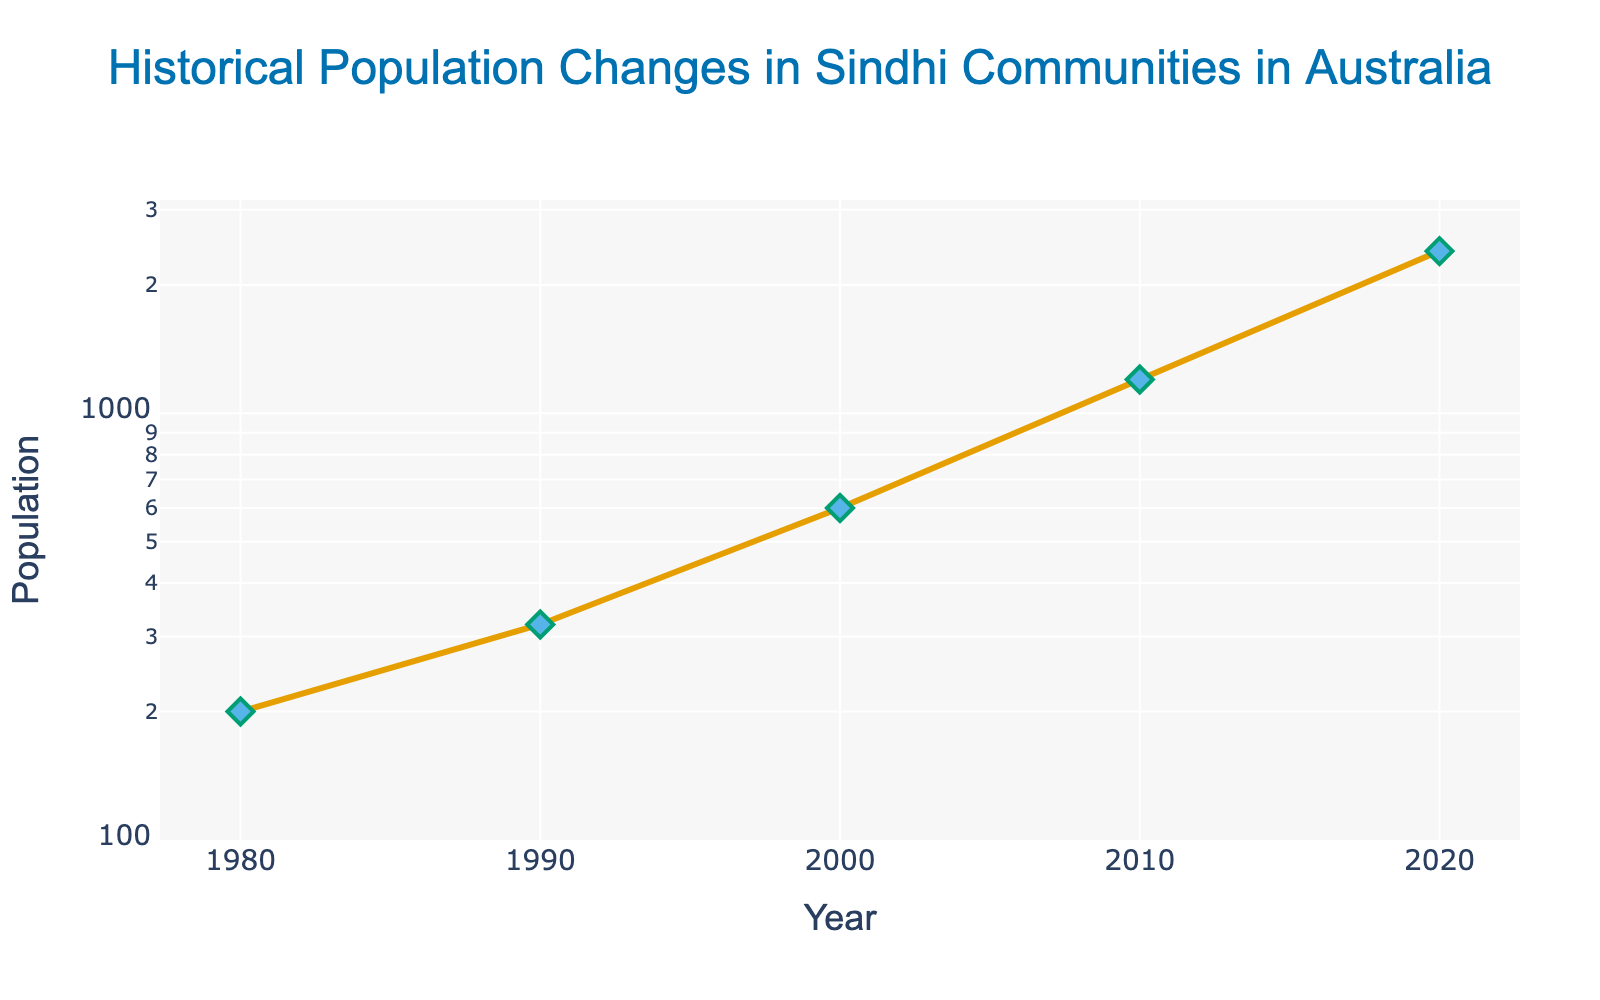What is the title of the figure? The title is prominently displayed at the top center of the figure.
Answer: Historical Population Changes in Sindhi Communities in Australia How many data points are plotted in the figure? The figure shows markers for each decade. By counting the markers, we can see there are 5 data points: 1980, 1990, 2000, 2010, and 2020.
Answer: 5 What is the population of Sindhi communities in Australia in 1990? The annotation on the marker for the year 1990 shows the population as 320.
Answer: 320 By what factor did the Sindhi community population in Australia increase from 2000 to 2010? The population in 2000 is 600, and in 2010, it's 1,200. To find the factor increase, divide the 2010 population by the 2000 population: 1200 / 600 = 2.
Answer: 2 During which decade did the Sindhi community population in Australia see the highest growth in absolute numbers? By examining the vertical distances between each point, the largest increase is between 2010 (1,200) and 2020 (2,400), with an absolute growth of 1,200.
Answer: 2010-2020 What is the y-axis type in the plot? The y-axis is presented in a log scale, as seen from the labeled logarithmic tick marks ranging from 2 to 3.5.
Answer: Logarithmic What is the total population change from 1980 to 2020? Subtract the 1980 population (200) from the 2020 population (2,400) to find the total change: 2,400 - 200 = 2,200.
Answer: 2,200 On average, how much did the population grow per decade from 1980 to 2020? Divide the total population change (2,200) by the number of decades (4): 2,200 / 4 = 550.
Answer: 550 Which decade had the least percentage growth in population? Calculate the percentage growth for each decade:
1. 1980-1990: ((320 - 200) / 200) * 100 = 60%
2. 1990-2000: ((600 - 320) / 320) * 100 = 87.5%
3. 2000-2010: ((1200 - 600) / 600) * 100 = 100%
4. 2010-2020: ((2400 - 1200) / 1200) * 100 = 100%
The least percentage growth is from 1980 to 1990.
Answer: 1980-1990 What color are the markers for the data points in the figure? Observing the markers, they are colored in light blue.
Answer: Light blue 